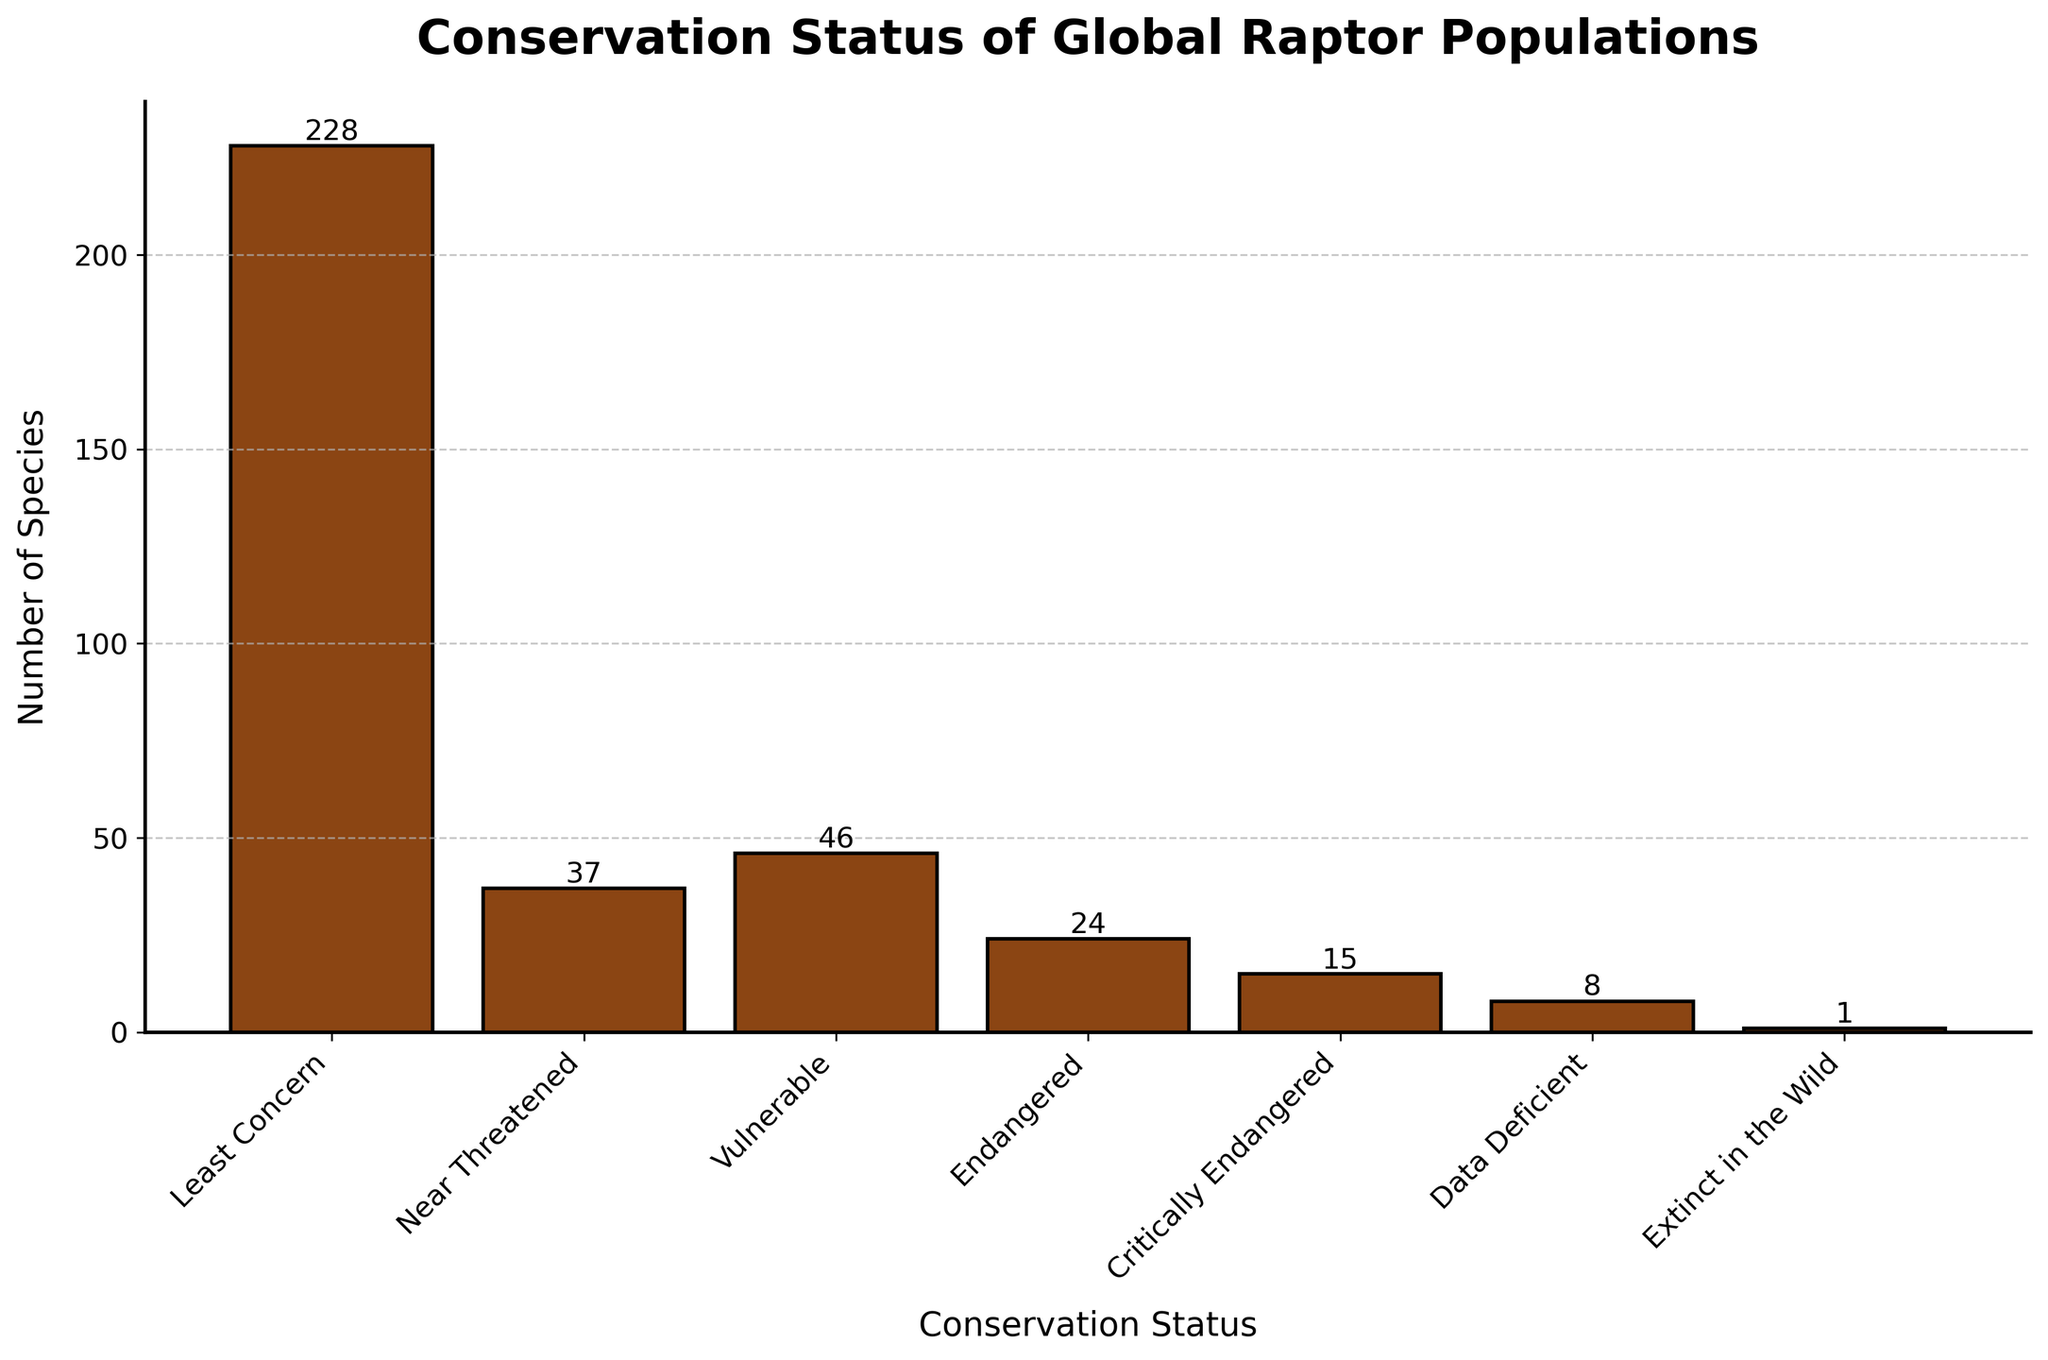What's the most common conservation status among global raptor populations? The bar with the highest value represents the most common conservation status. It is the "Least Concern" category with 228 species.
Answer: Least Concern How many more species are in the Least Concern status compared to the Near Threatened status? Subtract the number of species in the Near Threatened status from those in the Least Concern status: 228 - 37 = 191.
Answer: 191 Which conservation status has the fewest number of species? The shortest bar represents the conservation status with the fewest species. It is the "Extinct in the Wild" category with 1 species.
Answer: Extinct in the Wild What is the total number of raptor species listed under Endangered and Critically Endangered statuses? Sum the species in the Endangered and Critically Endangered categories: 24 + 15 = 39.
Answer: 39 Are there more raptor species listed as Near Threatened or Vulnerable? Compare the heights of the bars for Near Threatened and Vulnerable statuses. The Vulnerable category has 46 species which is more than the Near Threatened category with 37 species.
Answer: Vulnerable What percentage of the total species are listed as Critically Endangered? The total number of species is 359. Calculate the percentage: (15 / 359) * 100 ≈ 4.18%.
Answer: 4.18% How many species are listed under Data Deficient and Extinct in the Wild combined? Sum the species under Data Deficient and Extinct in the Wild categories: 8 + 1 = 9.
Answer: 9 What are the two least common conservation statuses? The two shortest bars represent the least common conservation statuses. They are "Extinct in the Wild" with 1 species and "Data Deficient" with 8 species.
Answer: Extinct in the Wild, Data Deficient How many times more species are listed as Least Concern compared to those listed as Critically Endangered? Divide the number of species in Least Concern by those in Critically Endangered: 228 / 15 ≈ 15.2.
Answer: 15.2 